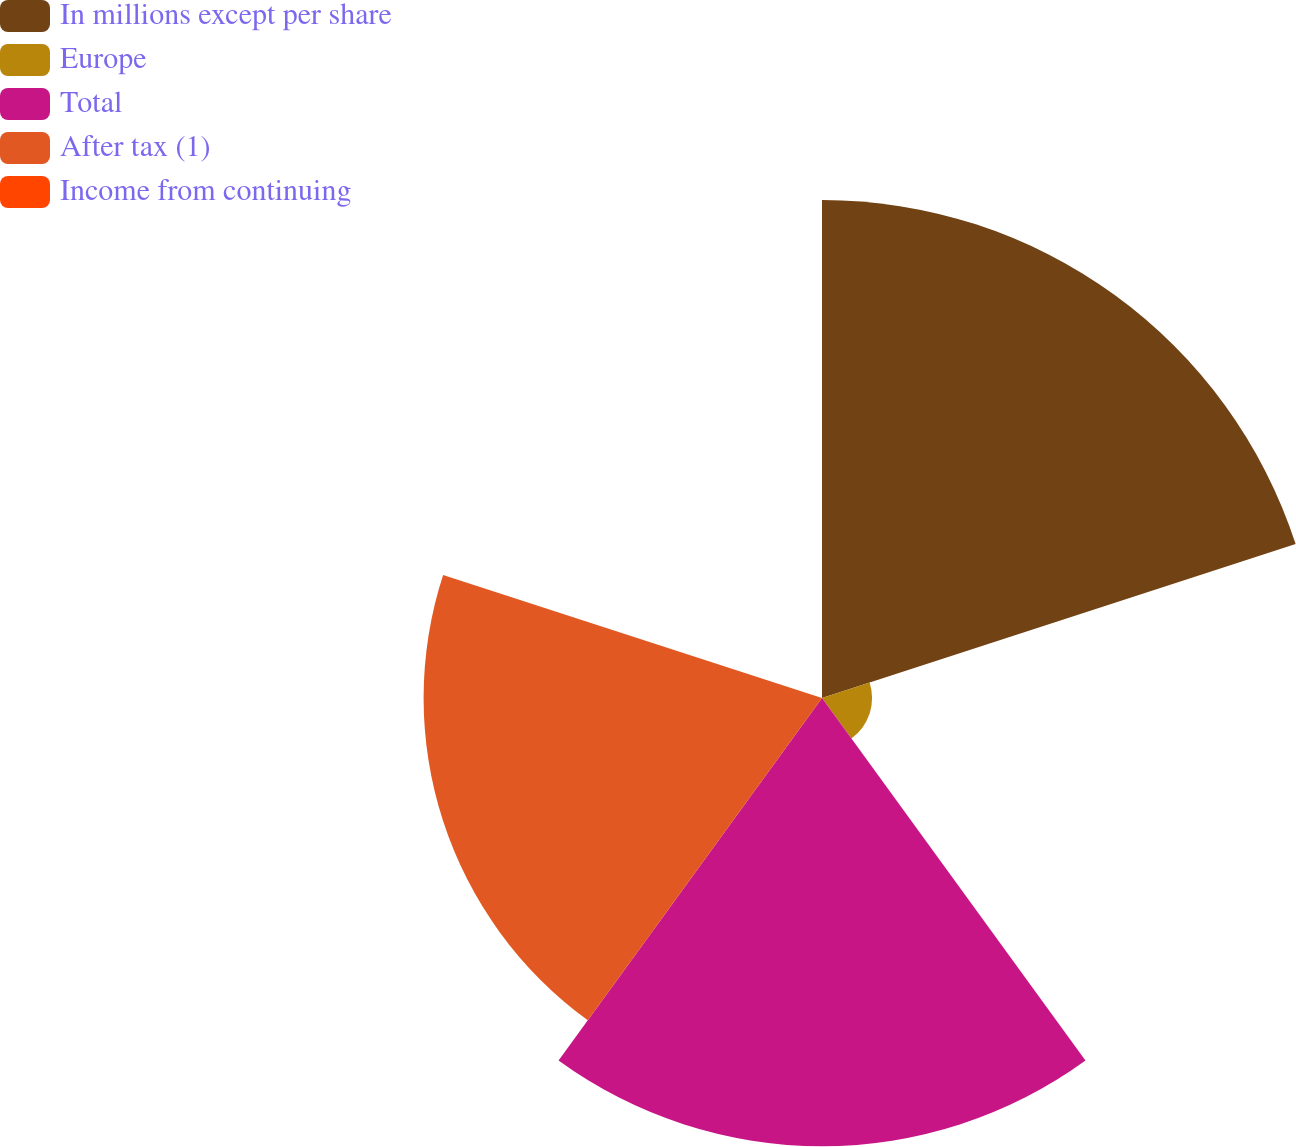Convert chart. <chart><loc_0><loc_0><loc_500><loc_500><pie_chart><fcel>In millions except per share<fcel>Europe<fcel>Total<fcel>After tax (1)<fcel>Income from continuing<nl><fcel>35.7%<fcel>3.59%<fcel>32.13%<fcel>28.56%<fcel>0.02%<nl></chart> 